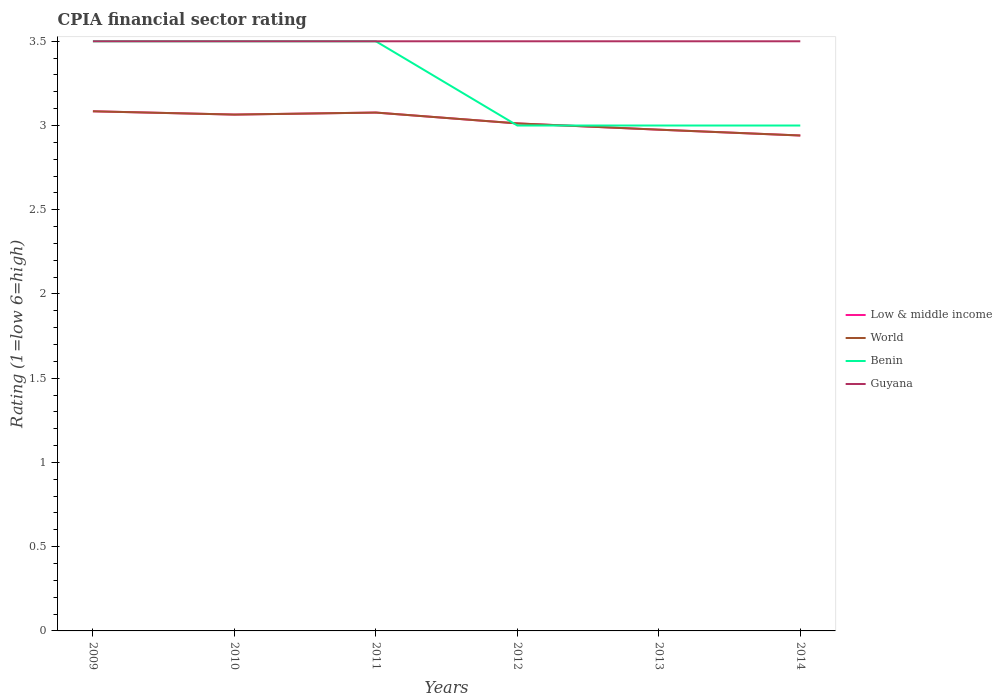How many different coloured lines are there?
Your answer should be compact. 4. Does the line corresponding to World intersect with the line corresponding to Benin?
Your answer should be very brief. Yes. Across all years, what is the maximum CPIA rating in Low & middle income?
Make the answer very short. 2.94. In which year was the CPIA rating in Benin maximum?
Keep it short and to the point. 2012. What is the difference between the highest and the second highest CPIA rating in Low & middle income?
Your answer should be compact. 0.14. Is the CPIA rating in Guyana strictly greater than the CPIA rating in Benin over the years?
Give a very brief answer. No. How many years are there in the graph?
Provide a short and direct response. 6. What is the difference between two consecutive major ticks on the Y-axis?
Offer a very short reply. 0.5. Are the values on the major ticks of Y-axis written in scientific E-notation?
Provide a succinct answer. No. Does the graph contain any zero values?
Give a very brief answer. No. Does the graph contain grids?
Give a very brief answer. No. How are the legend labels stacked?
Keep it short and to the point. Vertical. What is the title of the graph?
Your answer should be very brief. CPIA financial sector rating. What is the label or title of the X-axis?
Offer a terse response. Years. What is the label or title of the Y-axis?
Ensure brevity in your answer.  Rating (1=low 6=high). What is the Rating (1=low 6=high) of Low & middle income in 2009?
Keep it short and to the point. 3.08. What is the Rating (1=low 6=high) in World in 2009?
Provide a short and direct response. 3.08. What is the Rating (1=low 6=high) of Benin in 2009?
Offer a very short reply. 3.5. What is the Rating (1=low 6=high) in Guyana in 2009?
Keep it short and to the point. 3.5. What is the Rating (1=low 6=high) of Low & middle income in 2010?
Your answer should be compact. 3.06. What is the Rating (1=low 6=high) in World in 2010?
Provide a short and direct response. 3.06. What is the Rating (1=low 6=high) in Guyana in 2010?
Give a very brief answer. 3.5. What is the Rating (1=low 6=high) of Low & middle income in 2011?
Give a very brief answer. 3.08. What is the Rating (1=low 6=high) of World in 2011?
Offer a very short reply. 3.08. What is the Rating (1=low 6=high) of Guyana in 2011?
Give a very brief answer. 3.5. What is the Rating (1=low 6=high) in Low & middle income in 2012?
Offer a very short reply. 3.01. What is the Rating (1=low 6=high) of World in 2012?
Offer a terse response. 3.01. What is the Rating (1=low 6=high) in Guyana in 2012?
Provide a succinct answer. 3.5. What is the Rating (1=low 6=high) in Low & middle income in 2013?
Your response must be concise. 2.98. What is the Rating (1=low 6=high) in World in 2013?
Provide a short and direct response. 2.98. What is the Rating (1=low 6=high) in Low & middle income in 2014?
Your response must be concise. 2.94. What is the Rating (1=low 6=high) of World in 2014?
Offer a terse response. 2.94. What is the Rating (1=low 6=high) of Guyana in 2014?
Keep it short and to the point. 3.5. Across all years, what is the maximum Rating (1=low 6=high) of Low & middle income?
Your response must be concise. 3.08. Across all years, what is the maximum Rating (1=low 6=high) of World?
Give a very brief answer. 3.08. Across all years, what is the maximum Rating (1=low 6=high) in Guyana?
Ensure brevity in your answer.  3.5. Across all years, what is the minimum Rating (1=low 6=high) of Low & middle income?
Your answer should be compact. 2.94. Across all years, what is the minimum Rating (1=low 6=high) in World?
Your answer should be very brief. 2.94. Across all years, what is the minimum Rating (1=low 6=high) in Benin?
Offer a very short reply. 3. Across all years, what is the minimum Rating (1=low 6=high) in Guyana?
Provide a short and direct response. 3.5. What is the total Rating (1=low 6=high) in Low & middle income in the graph?
Keep it short and to the point. 18.15. What is the total Rating (1=low 6=high) in World in the graph?
Give a very brief answer. 18.15. What is the total Rating (1=low 6=high) of Benin in the graph?
Your response must be concise. 19.5. What is the total Rating (1=low 6=high) in Guyana in the graph?
Give a very brief answer. 21. What is the difference between the Rating (1=low 6=high) of Low & middle income in 2009 and that in 2010?
Offer a very short reply. 0.02. What is the difference between the Rating (1=low 6=high) in World in 2009 and that in 2010?
Keep it short and to the point. 0.02. What is the difference between the Rating (1=low 6=high) in Benin in 2009 and that in 2010?
Your answer should be very brief. 0. What is the difference between the Rating (1=low 6=high) in Guyana in 2009 and that in 2010?
Your response must be concise. 0. What is the difference between the Rating (1=low 6=high) of Low & middle income in 2009 and that in 2011?
Ensure brevity in your answer.  0.01. What is the difference between the Rating (1=low 6=high) of World in 2009 and that in 2011?
Make the answer very short. 0.01. What is the difference between the Rating (1=low 6=high) in Benin in 2009 and that in 2011?
Your answer should be very brief. 0. What is the difference between the Rating (1=low 6=high) of Guyana in 2009 and that in 2011?
Make the answer very short. 0. What is the difference between the Rating (1=low 6=high) of Low & middle income in 2009 and that in 2012?
Your response must be concise. 0.07. What is the difference between the Rating (1=low 6=high) in World in 2009 and that in 2012?
Your response must be concise. 0.07. What is the difference between the Rating (1=low 6=high) of Benin in 2009 and that in 2012?
Your response must be concise. 0.5. What is the difference between the Rating (1=low 6=high) of Guyana in 2009 and that in 2012?
Keep it short and to the point. 0. What is the difference between the Rating (1=low 6=high) in Low & middle income in 2009 and that in 2013?
Make the answer very short. 0.11. What is the difference between the Rating (1=low 6=high) of World in 2009 and that in 2013?
Your answer should be compact. 0.11. What is the difference between the Rating (1=low 6=high) of Benin in 2009 and that in 2013?
Your answer should be compact. 0.5. What is the difference between the Rating (1=low 6=high) of Guyana in 2009 and that in 2013?
Make the answer very short. 0. What is the difference between the Rating (1=low 6=high) of Low & middle income in 2009 and that in 2014?
Give a very brief answer. 0.14. What is the difference between the Rating (1=low 6=high) in World in 2009 and that in 2014?
Your answer should be compact. 0.14. What is the difference between the Rating (1=low 6=high) in Guyana in 2009 and that in 2014?
Provide a succinct answer. 0. What is the difference between the Rating (1=low 6=high) of Low & middle income in 2010 and that in 2011?
Give a very brief answer. -0.01. What is the difference between the Rating (1=low 6=high) in World in 2010 and that in 2011?
Provide a succinct answer. -0.01. What is the difference between the Rating (1=low 6=high) of Benin in 2010 and that in 2011?
Your answer should be compact. 0. What is the difference between the Rating (1=low 6=high) of Guyana in 2010 and that in 2011?
Offer a very short reply. 0. What is the difference between the Rating (1=low 6=high) of Low & middle income in 2010 and that in 2012?
Give a very brief answer. 0.05. What is the difference between the Rating (1=low 6=high) of World in 2010 and that in 2012?
Ensure brevity in your answer.  0.05. What is the difference between the Rating (1=low 6=high) of Low & middle income in 2010 and that in 2013?
Your answer should be very brief. 0.09. What is the difference between the Rating (1=low 6=high) in World in 2010 and that in 2013?
Ensure brevity in your answer.  0.09. What is the difference between the Rating (1=low 6=high) in Low & middle income in 2010 and that in 2014?
Offer a terse response. 0.12. What is the difference between the Rating (1=low 6=high) in World in 2010 and that in 2014?
Offer a terse response. 0.12. What is the difference between the Rating (1=low 6=high) in Guyana in 2010 and that in 2014?
Offer a very short reply. 0. What is the difference between the Rating (1=low 6=high) of Low & middle income in 2011 and that in 2012?
Keep it short and to the point. 0.06. What is the difference between the Rating (1=low 6=high) in World in 2011 and that in 2012?
Offer a very short reply. 0.06. What is the difference between the Rating (1=low 6=high) of Benin in 2011 and that in 2012?
Give a very brief answer. 0.5. What is the difference between the Rating (1=low 6=high) of Guyana in 2011 and that in 2012?
Make the answer very short. 0. What is the difference between the Rating (1=low 6=high) in Low & middle income in 2011 and that in 2013?
Give a very brief answer. 0.1. What is the difference between the Rating (1=low 6=high) in World in 2011 and that in 2013?
Your response must be concise. 0.1. What is the difference between the Rating (1=low 6=high) of Guyana in 2011 and that in 2013?
Offer a terse response. 0. What is the difference between the Rating (1=low 6=high) of Low & middle income in 2011 and that in 2014?
Keep it short and to the point. 0.14. What is the difference between the Rating (1=low 6=high) of World in 2011 and that in 2014?
Offer a terse response. 0.14. What is the difference between the Rating (1=low 6=high) of Benin in 2011 and that in 2014?
Offer a terse response. 0.5. What is the difference between the Rating (1=low 6=high) of Low & middle income in 2012 and that in 2013?
Provide a short and direct response. 0.04. What is the difference between the Rating (1=low 6=high) in World in 2012 and that in 2013?
Offer a terse response. 0.04. What is the difference between the Rating (1=low 6=high) in Benin in 2012 and that in 2013?
Give a very brief answer. 0. What is the difference between the Rating (1=low 6=high) in Guyana in 2012 and that in 2013?
Your answer should be very brief. 0. What is the difference between the Rating (1=low 6=high) of Low & middle income in 2012 and that in 2014?
Offer a terse response. 0.07. What is the difference between the Rating (1=low 6=high) in World in 2012 and that in 2014?
Ensure brevity in your answer.  0.07. What is the difference between the Rating (1=low 6=high) in Guyana in 2012 and that in 2014?
Keep it short and to the point. 0. What is the difference between the Rating (1=low 6=high) of Low & middle income in 2013 and that in 2014?
Offer a terse response. 0.03. What is the difference between the Rating (1=low 6=high) in World in 2013 and that in 2014?
Offer a very short reply. 0.03. What is the difference between the Rating (1=low 6=high) in Benin in 2013 and that in 2014?
Your response must be concise. 0. What is the difference between the Rating (1=low 6=high) in Low & middle income in 2009 and the Rating (1=low 6=high) in World in 2010?
Provide a succinct answer. 0.02. What is the difference between the Rating (1=low 6=high) of Low & middle income in 2009 and the Rating (1=low 6=high) of Benin in 2010?
Provide a short and direct response. -0.42. What is the difference between the Rating (1=low 6=high) in Low & middle income in 2009 and the Rating (1=low 6=high) in Guyana in 2010?
Offer a very short reply. -0.42. What is the difference between the Rating (1=low 6=high) in World in 2009 and the Rating (1=low 6=high) in Benin in 2010?
Give a very brief answer. -0.42. What is the difference between the Rating (1=low 6=high) of World in 2009 and the Rating (1=low 6=high) of Guyana in 2010?
Provide a short and direct response. -0.42. What is the difference between the Rating (1=low 6=high) in Low & middle income in 2009 and the Rating (1=low 6=high) in World in 2011?
Make the answer very short. 0.01. What is the difference between the Rating (1=low 6=high) of Low & middle income in 2009 and the Rating (1=low 6=high) of Benin in 2011?
Offer a terse response. -0.42. What is the difference between the Rating (1=low 6=high) in Low & middle income in 2009 and the Rating (1=low 6=high) in Guyana in 2011?
Make the answer very short. -0.42. What is the difference between the Rating (1=low 6=high) of World in 2009 and the Rating (1=low 6=high) of Benin in 2011?
Provide a succinct answer. -0.42. What is the difference between the Rating (1=low 6=high) in World in 2009 and the Rating (1=low 6=high) in Guyana in 2011?
Keep it short and to the point. -0.42. What is the difference between the Rating (1=low 6=high) of Benin in 2009 and the Rating (1=low 6=high) of Guyana in 2011?
Your response must be concise. 0. What is the difference between the Rating (1=low 6=high) of Low & middle income in 2009 and the Rating (1=low 6=high) of World in 2012?
Ensure brevity in your answer.  0.07. What is the difference between the Rating (1=low 6=high) in Low & middle income in 2009 and the Rating (1=low 6=high) in Benin in 2012?
Offer a very short reply. 0.08. What is the difference between the Rating (1=low 6=high) of Low & middle income in 2009 and the Rating (1=low 6=high) of Guyana in 2012?
Keep it short and to the point. -0.42. What is the difference between the Rating (1=low 6=high) in World in 2009 and the Rating (1=low 6=high) in Benin in 2012?
Make the answer very short. 0.08. What is the difference between the Rating (1=low 6=high) in World in 2009 and the Rating (1=low 6=high) in Guyana in 2012?
Make the answer very short. -0.42. What is the difference between the Rating (1=low 6=high) of Low & middle income in 2009 and the Rating (1=low 6=high) of World in 2013?
Make the answer very short. 0.11. What is the difference between the Rating (1=low 6=high) of Low & middle income in 2009 and the Rating (1=low 6=high) of Benin in 2013?
Provide a short and direct response. 0.08. What is the difference between the Rating (1=low 6=high) of Low & middle income in 2009 and the Rating (1=low 6=high) of Guyana in 2013?
Your answer should be very brief. -0.42. What is the difference between the Rating (1=low 6=high) in World in 2009 and the Rating (1=low 6=high) in Benin in 2013?
Offer a very short reply. 0.08. What is the difference between the Rating (1=low 6=high) of World in 2009 and the Rating (1=low 6=high) of Guyana in 2013?
Offer a terse response. -0.42. What is the difference between the Rating (1=low 6=high) in Benin in 2009 and the Rating (1=low 6=high) in Guyana in 2013?
Your answer should be compact. 0. What is the difference between the Rating (1=low 6=high) of Low & middle income in 2009 and the Rating (1=low 6=high) of World in 2014?
Your answer should be compact. 0.14. What is the difference between the Rating (1=low 6=high) of Low & middle income in 2009 and the Rating (1=low 6=high) of Benin in 2014?
Give a very brief answer. 0.08. What is the difference between the Rating (1=low 6=high) of Low & middle income in 2009 and the Rating (1=low 6=high) of Guyana in 2014?
Your response must be concise. -0.42. What is the difference between the Rating (1=low 6=high) in World in 2009 and the Rating (1=low 6=high) in Benin in 2014?
Make the answer very short. 0.08. What is the difference between the Rating (1=low 6=high) of World in 2009 and the Rating (1=low 6=high) of Guyana in 2014?
Your answer should be very brief. -0.42. What is the difference between the Rating (1=low 6=high) of Benin in 2009 and the Rating (1=low 6=high) of Guyana in 2014?
Offer a terse response. 0. What is the difference between the Rating (1=low 6=high) of Low & middle income in 2010 and the Rating (1=low 6=high) of World in 2011?
Offer a terse response. -0.01. What is the difference between the Rating (1=low 6=high) of Low & middle income in 2010 and the Rating (1=low 6=high) of Benin in 2011?
Keep it short and to the point. -0.44. What is the difference between the Rating (1=low 6=high) in Low & middle income in 2010 and the Rating (1=low 6=high) in Guyana in 2011?
Your answer should be compact. -0.44. What is the difference between the Rating (1=low 6=high) of World in 2010 and the Rating (1=low 6=high) of Benin in 2011?
Provide a short and direct response. -0.44. What is the difference between the Rating (1=low 6=high) in World in 2010 and the Rating (1=low 6=high) in Guyana in 2011?
Provide a succinct answer. -0.44. What is the difference between the Rating (1=low 6=high) in Low & middle income in 2010 and the Rating (1=low 6=high) in World in 2012?
Your answer should be very brief. 0.05. What is the difference between the Rating (1=low 6=high) in Low & middle income in 2010 and the Rating (1=low 6=high) in Benin in 2012?
Your answer should be compact. 0.06. What is the difference between the Rating (1=low 6=high) in Low & middle income in 2010 and the Rating (1=low 6=high) in Guyana in 2012?
Ensure brevity in your answer.  -0.44. What is the difference between the Rating (1=low 6=high) of World in 2010 and the Rating (1=low 6=high) of Benin in 2012?
Keep it short and to the point. 0.06. What is the difference between the Rating (1=low 6=high) of World in 2010 and the Rating (1=low 6=high) of Guyana in 2012?
Offer a very short reply. -0.44. What is the difference between the Rating (1=low 6=high) of Benin in 2010 and the Rating (1=low 6=high) of Guyana in 2012?
Your answer should be compact. 0. What is the difference between the Rating (1=low 6=high) in Low & middle income in 2010 and the Rating (1=low 6=high) in World in 2013?
Provide a succinct answer. 0.09. What is the difference between the Rating (1=low 6=high) of Low & middle income in 2010 and the Rating (1=low 6=high) of Benin in 2013?
Offer a very short reply. 0.06. What is the difference between the Rating (1=low 6=high) in Low & middle income in 2010 and the Rating (1=low 6=high) in Guyana in 2013?
Provide a succinct answer. -0.44. What is the difference between the Rating (1=low 6=high) of World in 2010 and the Rating (1=low 6=high) of Benin in 2013?
Provide a succinct answer. 0.06. What is the difference between the Rating (1=low 6=high) of World in 2010 and the Rating (1=low 6=high) of Guyana in 2013?
Offer a terse response. -0.44. What is the difference between the Rating (1=low 6=high) of Benin in 2010 and the Rating (1=low 6=high) of Guyana in 2013?
Make the answer very short. 0. What is the difference between the Rating (1=low 6=high) in Low & middle income in 2010 and the Rating (1=low 6=high) in World in 2014?
Provide a short and direct response. 0.12. What is the difference between the Rating (1=low 6=high) in Low & middle income in 2010 and the Rating (1=low 6=high) in Benin in 2014?
Your response must be concise. 0.06. What is the difference between the Rating (1=low 6=high) in Low & middle income in 2010 and the Rating (1=low 6=high) in Guyana in 2014?
Your answer should be very brief. -0.44. What is the difference between the Rating (1=low 6=high) of World in 2010 and the Rating (1=low 6=high) of Benin in 2014?
Provide a succinct answer. 0.06. What is the difference between the Rating (1=low 6=high) of World in 2010 and the Rating (1=low 6=high) of Guyana in 2014?
Your answer should be very brief. -0.44. What is the difference between the Rating (1=low 6=high) in Benin in 2010 and the Rating (1=low 6=high) in Guyana in 2014?
Make the answer very short. 0. What is the difference between the Rating (1=low 6=high) in Low & middle income in 2011 and the Rating (1=low 6=high) in World in 2012?
Make the answer very short. 0.06. What is the difference between the Rating (1=low 6=high) of Low & middle income in 2011 and the Rating (1=low 6=high) of Benin in 2012?
Make the answer very short. 0.08. What is the difference between the Rating (1=low 6=high) in Low & middle income in 2011 and the Rating (1=low 6=high) in Guyana in 2012?
Offer a terse response. -0.42. What is the difference between the Rating (1=low 6=high) of World in 2011 and the Rating (1=low 6=high) of Benin in 2012?
Your response must be concise. 0.08. What is the difference between the Rating (1=low 6=high) of World in 2011 and the Rating (1=low 6=high) of Guyana in 2012?
Offer a terse response. -0.42. What is the difference between the Rating (1=low 6=high) in Benin in 2011 and the Rating (1=low 6=high) in Guyana in 2012?
Offer a terse response. 0. What is the difference between the Rating (1=low 6=high) of Low & middle income in 2011 and the Rating (1=low 6=high) of World in 2013?
Provide a short and direct response. 0.1. What is the difference between the Rating (1=low 6=high) in Low & middle income in 2011 and the Rating (1=low 6=high) in Benin in 2013?
Give a very brief answer. 0.08. What is the difference between the Rating (1=low 6=high) in Low & middle income in 2011 and the Rating (1=low 6=high) in Guyana in 2013?
Ensure brevity in your answer.  -0.42. What is the difference between the Rating (1=low 6=high) in World in 2011 and the Rating (1=low 6=high) in Benin in 2013?
Provide a short and direct response. 0.08. What is the difference between the Rating (1=low 6=high) of World in 2011 and the Rating (1=low 6=high) of Guyana in 2013?
Provide a short and direct response. -0.42. What is the difference between the Rating (1=low 6=high) of Low & middle income in 2011 and the Rating (1=low 6=high) of World in 2014?
Your response must be concise. 0.14. What is the difference between the Rating (1=low 6=high) of Low & middle income in 2011 and the Rating (1=low 6=high) of Benin in 2014?
Offer a terse response. 0.08. What is the difference between the Rating (1=low 6=high) in Low & middle income in 2011 and the Rating (1=low 6=high) in Guyana in 2014?
Provide a succinct answer. -0.42. What is the difference between the Rating (1=low 6=high) in World in 2011 and the Rating (1=low 6=high) in Benin in 2014?
Provide a succinct answer. 0.08. What is the difference between the Rating (1=low 6=high) of World in 2011 and the Rating (1=low 6=high) of Guyana in 2014?
Your response must be concise. -0.42. What is the difference between the Rating (1=low 6=high) in Benin in 2011 and the Rating (1=low 6=high) in Guyana in 2014?
Provide a short and direct response. 0. What is the difference between the Rating (1=low 6=high) in Low & middle income in 2012 and the Rating (1=low 6=high) in World in 2013?
Your answer should be very brief. 0.04. What is the difference between the Rating (1=low 6=high) in Low & middle income in 2012 and the Rating (1=low 6=high) in Benin in 2013?
Provide a succinct answer. 0.01. What is the difference between the Rating (1=low 6=high) of Low & middle income in 2012 and the Rating (1=low 6=high) of Guyana in 2013?
Offer a terse response. -0.49. What is the difference between the Rating (1=low 6=high) of World in 2012 and the Rating (1=low 6=high) of Benin in 2013?
Your answer should be very brief. 0.01. What is the difference between the Rating (1=low 6=high) in World in 2012 and the Rating (1=low 6=high) in Guyana in 2013?
Your answer should be compact. -0.49. What is the difference between the Rating (1=low 6=high) in Benin in 2012 and the Rating (1=low 6=high) in Guyana in 2013?
Offer a very short reply. -0.5. What is the difference between the Rating (1=low 6=high) in Low & middle income in 2012 and the Rating (1=low 6=high) in World in 2014?
Keep it short and to the point. 0.07. What is the difference between the Rating (1=low 6=high) of Low & middle income in 2012 and the Rating (1=low 6=high) of Benin in 2014?
Give a very brief answer. 0.01. What is the difference between the Rating (1=low 6=high) in Low & middle income in 2012 and the Rating (1=low 6=high) in Guyana in 2014?
Keep it short and to the point. -0.49. What is the difference between the Rating (1=low 6=high) of World in 2012 and the Rating (1=low 6=high) of Benin in 2014?
Provide a succinct answer. 0.01. What is the difference between the Rating (1=low 6=high) in World in 2012 and the Rating (1=low 6=high) in Guyana in 2014?
Give a very brief answer. -0.49. What is the difference between the Rating (1=low 6=high) in Low & middle income in 2013 and the Rating (1=low 6=high) in World in 2014?
Your answer should be compact. 0.03. What is the difference between the Rating (1=low 6=high) in Low & middle income in 2013 and the Rating (1=low 6=high) in Benin in 2014?
Give a very brief answer. -0.02. What is the difference between the Rating (1=low 6=high) in Low & middle income in 2013 and the Rating (1=low 6=high) in Guyana in 2014?
Offer a terse response. -0.52. What is the difference between the Rating (1=low 6=high) of World in 2013 and the Rating (1=low 6=high) of Benin in 2014?
Provide a short and direct response. -0.02. What is the difference between the Rating (1=low 6=high) in World in 2013 and the Rating (1=low 6=high) in Guyana in 2014?
Provide a succinct answer. -0.52. What is the average Rating (1=low 6=high) of Low & middle income per year?
Your answer should be compact. 3.03. What is the average Rating (1=low 6=high) of World per year?
Provide a succinct answer. 3.03. In the year 2009, what is the difference between the Rating (1=low 6=high) in Low & middle income and Rating (1=low 6=high) in Benin?
Ensure brevity in your answer.  -0.42. In the year 2009, what is the difference between the Rating (1=low 6=high) of Low & middle income and Rating (1=low 6=high) of Guyana?
Offer a terse response. -0.42. In the year 2009, what is the difference between the Rating (1=low 6=high) in World and Rating (1=low 6=high) in Benin?
Provide a short and direct response. -0.42. In the year 2009, what is the difference between the Rating (1=low 6=high) in World and Rating (1=low 6=high) in Guyana?
Keep it short and to the point. -0.42. In the year 2010, what is the difference between the Rating (1=low 6=high) in Low & middle income and Rating (1=low 6=high) in Benin?
Your response must be concise. -0.44. In the year 2010, what is the difference between the Rating (1=low 6=high) in Low & middle income and Rating (1=low 6=high) in Guyana?
Give a very brief answer. -0.44. In the year 2010, what is the difference between the Rating (1=low 6=high) of World and Rating (1=low 6=high) of Benin?
Offer a very short reply. -0.44. In the year 2010, what is the difference between the Rating (1=low 6=high) of World and Rating (1=low 6=high) of Guyana?
Offer a terse response. -0.44. In the year 2011, what is the difference between the Rating (1=low 6=high) of Low & middle income and Rating (1=low 6=high) of Benin?
Your answer should be compact. -0.42. In the year 2011, what is the difference between the Rating (1=low 6=high) of Low & middle income and Rating (1=low 6=high) of Guyana?
Keep it short and to the point. -0.42. In the year 2011, what is the difference between the Rating (1=low 6=high) of World and Rating (1=low 6=high) of Benin?
Your answer should be compact. -0.42. In the year 2011, what is the difference between the Rating (1=low 6=high) of World and Rating (1=low 6=high) of Guyana?
Give a very brief answer. -0.42. In the year 2012, what is the difference between the Rating (1=low 6=high) of Low & middle income and Rating (1=low 6=high) of World?
Ensure brevity in your answer.  0. In the year 2012, what is the difference between the Rating (1=low 6=high) of Low & middle income and Rating (1=low 6=high) of Benin?
Your answer should be compact. 0.01. In the year 2012, what is the difference between the Rating (1=low 6=high) in Low & middle income and Rating (1=low 6=high) in Guyana?
Your answer should be compact. -0.49. In the year 2012, what is the difference between the Rating (1=low 6=high) of World and Rating (1=low 6=high) of Benin?
Ensure brevity in your answer.  0.01. In the year 2012, what is the difference between the Rating (1=low 6=high) of World and Rating (1=low 6=high) of Guyana?
Provide a short and direct response. -0.49. In the year 2012, what is the difference between the Rating (1=low 6=high) in Benin and Rating (1=low 6=high) in Guyana?
Your answer should be compact. -0.5. In the year 2013, what is the difference between the Rating (1=low 6=high) in Low & middle income and Rating (1=low 6=high) in Benin?
Your answer should be compact. -0.02. In the year 2013, what is the difference between the Rating (1=low 6=high) in Low & middle income and Rating (1=low 6=high) in Guyana?
Offer a terse response. -0.52. In the year 2013, what is the difference between the Rating (1=low 6=high) of World and Rating (1=low 6=high) of Benin?
Offer a terse response. -0.02. In the year 2013, what is the difference between the Rating (1=low 6=high) of World and Rating (1=low 6=high) of Guyana?
Your answer should be compact. -0.52. In the year 2014, what is the difference between the Rating (1=low 6=high) of Low & middle income and Rating (1=low 6=high) of World?
Give a very brief answer. 0. In the year 2014, what is the difference between the Rating (1=low 6=high) in Low & middle income and Rating (1=low 6=high) in Benin?
Keep it short and to the point. -0.06. In the year 2014, what is the difference between the Rating (1=low 6=high) of Low & middle income and Rating (1=low 6=high) of Guyana?
Provide a short and direct response. -0.56. In the year 2014, what is the difference between the Rating (1=low 6=high) in World and Rating (1=low 6=high) in Benin?
Make the answer very short. -0.06. In the year 2014, what is the difference between the Rating (1=low 6=high) in World and Rating (1=low 6=high) in Guyana?
Offer a terse response. -0.56. In the year 2014, what is the difference between the Rating (1=low 6=high) in Benin and Rating (1=low 6=high) in Guyana?
Your answer should be very brief. -0.5. What is the ratio of the Rating (1=low 6=high) of Low & middle income in 2009 to that in 2010?
Make the answer very short. 1.01. What is the ratio of the Rating (1=low 6=high) of World in 2009 to that in 2010?
Give a very brief answer. 1.01. What is the ratio of the Rating (1=low 6=high) of Benin in 2009 to that in 2010?
Provide a succinct answer. 1. What is the ratio of the Rating (1=low 6=high) of Low & middle income in 2009 to that in 2011?
Provide a succinct answer. 1. What is the ratio of the Rating (1=low 6=high) in World in 2009 to that in 2011?
Your answer should be very brief. 1. What is the ratio of the Rating (1=low 6=high) in Benin in 2009 to that in 2011?
Keep it short and to the point. 1. What is the ratio of the Rating (1=low 6=high) in Guyana in 2009 to that in 2011?
Give a very brief answer. 1. What is the ratio of the Rating (1=low 6=high) in Low & middle income in 2009 to that in 2012?
Offer a very short reply. 1.02. What is the ratio of the Rating (1=low 6=high) in World in 2009 to that in 2012?
Your answer should be compact. 1.02. What is the ratio of the Rating (1=low 6=high) in Benin in 2009 to that in 2012?
Offer a terse response. 1.17. What is the ratio of the Rating (1=low 6=high) in Guyana in 2009 to that in 2012?
Make the answer very short. 1. What is the ratio of the Rating (1=low 6=high) of Low & middle income in 2009 to that in 2013?
Offer a very short reply. 1.04. What is the ratio of the Rating (1=low 6=high) in World in 2009 to that in 2013?
Your response must be concise. 1.04. What is the ratio of the Rating (1=low 6=high) in Guyana in 2009 to that in 2013?
Your response must be concise. 1. What is the ratio of the Rating (1=low 6=high) in Low & middle income in 2009 to that in 2014?
Your answer should be compact. 1.05. What is the ratio of the Rating (1=low 6=high) of World in 2009 to that in 2014?
Provide a short and direct response. 1.05. What is the ratio of the Rating (1=low 6=high) of Benin in 2009 to that in 2014?
Keep it short and to the point. 1.17. What is the ratio of the Rating (1=low 6=high) in Guyana in 2009 to that in 2014?
Offer a terse response. 1. What is the ratio of the Rating (1=low 6=high) of World in 2010 to that in 2011?
Make the answer very short. 1. What is the ratio of the Rating (1=low 6=high) of Guyana in 2010 to that in 2011?
Your response must be concise. 1. What is the ratio of the Rating (1=low 6=high) of Low & middle income in 2010 to that in 2012?
Your response must be concise. 1.02. What is the ratio of the Rating (1=low 6=high) in World in 2010 to that in 2012?
Provide a succinct answer. 1.02. What is the ratio of the Rating (1=low 6=high) of Benin in 2010 to that in 2012?
Your answer should be compact. 1.17. What is the ratio of the Rating (1=low 6=high) in Low & middle income in 2010 to that in 2013?
Ensure brevity in your answer.  1.03. What is the ratio of the Rating (1=low 6=high) of World in 2010 to that in 2013?
Offer a terse response. 1.03. What is the ratio of the Rating (1=low 6=high) in Guyana in 2010 to that in 2013?
Your response must be concise. 1. What is the ratio of the Rating (1=low 6=high) of Low & middle income in 2010 to that in 2014?
Ensure brevity in your answer.  1.04. What is the ratio of the Rating (1=low 6=high) of World in 2010 to that in 2014?
Your answer should be very brief. 1.04. What is the ratio of the Rating (1=low 6=high) in Benin in 2010 to that in 2014?
Your response must be concise. 1.17. What is the ratio of the Rating (1=low 6=high) in Low & middle income in 2011 to that in 2012?
Your answer should be compact. 1.02. What is the ratio of the Rating (1=low 6=high) in World in 2011 to that in 2012?
Ensure brevity in your answer.  1.02. What is the ratio of the Rating (1=low 6=high) of Guyana in 2011 to that in 2012?
Your response must be concise. 1. What is the ratio of the Rating (1=low 6=high) of Low & middle income in 2011 to that in 2013?
Offer a terse response. 1.03. What is the ratio of the Rating (1=low 6=high) in World in 2011 to that in 2013?
Your answer should be very brief. 1.03. What is the ratio of the Rating (1=low 6=high) in Benin in 2011 to that in 2013?
Make the answer very short. 1.17. What is the ratio of the Rating (1=low 6=high) in Low & middle income in 2011 to that in 2014?
Give a very brief answer. 1.05. What is the ratio of the Rating (1=low 6=high) in World in 2011 to that in 2014?
Make the answer very short. 1.05. What is the ratio of the Rating (1=low 6=high) of Guyana in 2011 to that in 2014?
Offer a terse response. 1. What is the ratio of the Rating (1=low 6=high) in Low & middle income in 2012 to that in 2013?
Provide a short and direct response. 1.01. What is the ratio of the Rating (1=low 6=high) of World in 2012 to that in 2013?
Your response must be concise. 1.01. What is the ratio of the Rating (1=low 6=high) in Guyana in 2012 to that in 2013?
Your answer should be very brief. 1. What is the ratio of the Rating (1=low 6=high) in Low & middle income in 2012 to that in 2014?
Make the answer very short. 1.02. What is the ratio of the Rating (1=low 6=high) in World in 2012 to that in 2014?
Your answer should be compact. 1.02. What is the ratio of the Rating (1=low 6=high) of Guyana in 2012 to that in 2014?
Provide a short and direct response. 1. What is the ratio of the Rating (1=low 6=high) in Low & middle income in 2013 to that in 2014?
Offer a very short reply. 1.01. What is the ratio of the Rating (1=low 6=high) in World in 2013 to that in 2014?
Provide a succinct answer. 1.01. What is the ratio of the Rating (1=low 6=high) in Benin in 2013 to that in 2014?
Ensure brevity in your answer.  1. What is the ratio of the Rating (1=low 6=high) of Guyana in 2013 to that in 2014?
Offer a very short reply. 1. What is the difference between the highest and the second highest Rating (1=low 6=high) of Low & middle income?
Provide a short and direct response. 0.01. What is the difference between the highest and the second highest Rating (1=low 6=high) in World?
Make the answer very short. 0.01. What is the difference between the highest and the second highest Rating (1=low 6=high) in Guyana?
Your response must be concise. 0. What is the difference between the highest and the lowest Rating (1=low 6=high) in Low & middle income?
Ensure brevity in your answer.  0.14. What is the difference between the highest and the lowest Rating (1=low 6=high) in World?
Your response must be concise. 0.14. What is the difference between the highest and the lowest Rating (1=low 6=high) in Benin?
Provide a short and direct response. 0.5. 